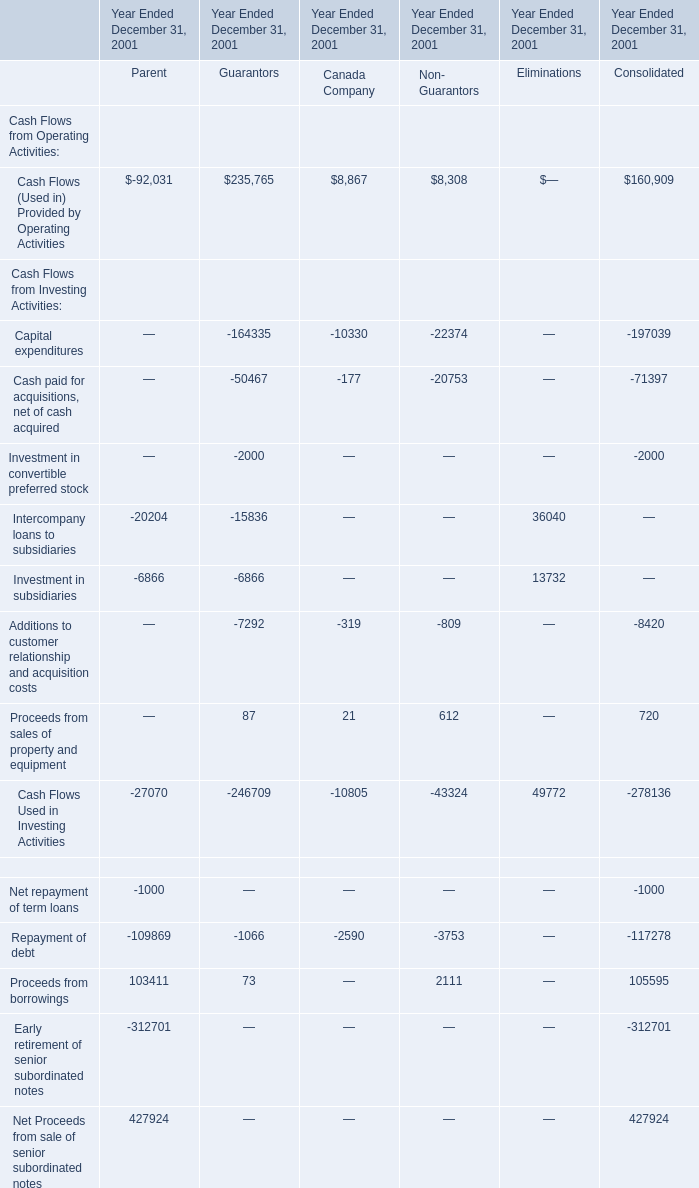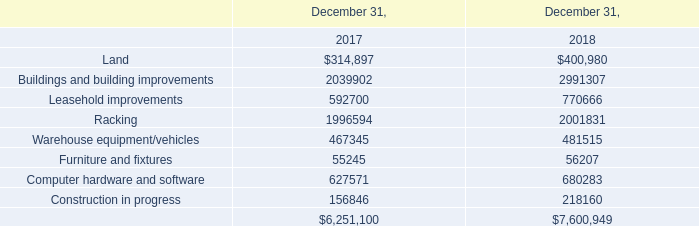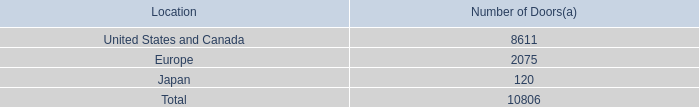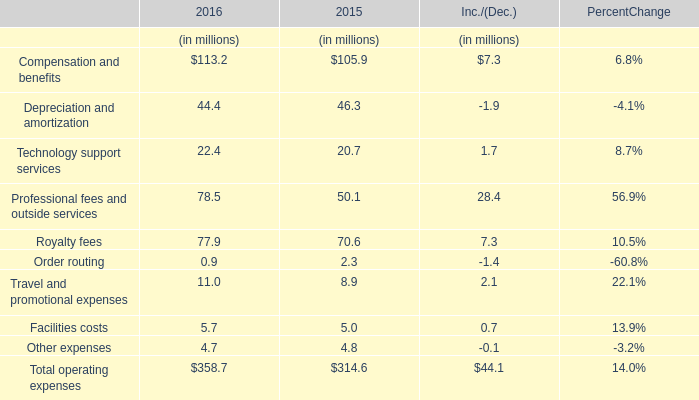what is the highest total amount of Cash Flows (Used in) Provided by Operating Activities? 
Answer: 235765. 